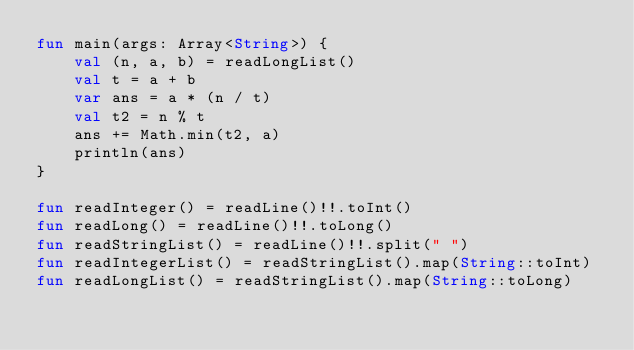<code> <loc_0><loc_0><loc_500><loc_500><_Kotlin_>fun main(args: Array<String>) {
    val (n, a, b) = readLongList()
    val t = a + b
    var ans = a * (n / t)
    val t2 = n % t
    ans += Math.min(t2, a)
    println(ans)
}

fun readInteger() = readLine()!!.toInt()
fun readLong() = readLine()!!.toLong()
fun readStringList() = readLine()!!.split(" ")
fun readIntegerList() = readStringList().map(String::toInt)
fun readLongList() = readStringList().map(String::toLong)
</code> 